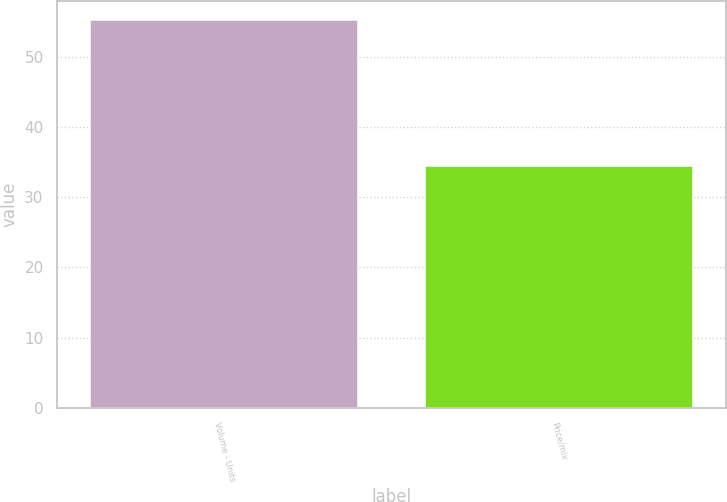<chart> <loc_0><loc_0><loc_500><loc_500><bar_chart><fcel>Volume - Units<fcel>Price/mix<nl><fcel>55.2<fcel>34.4<nl></chart> 